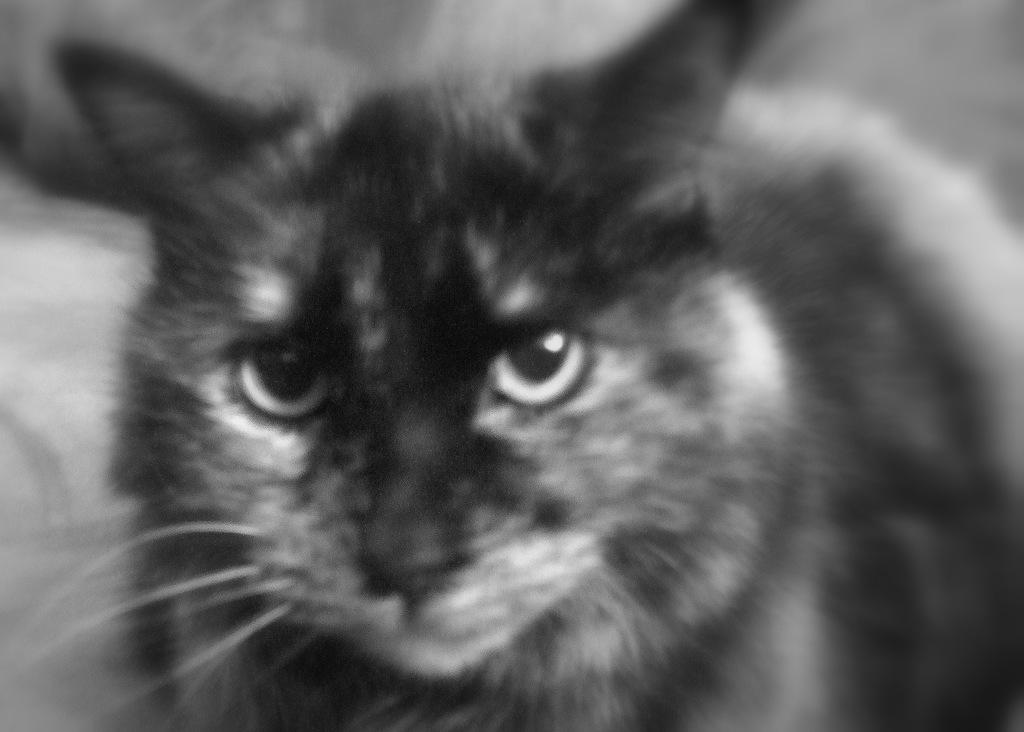What is the color scheme of the image? The image is black and white. What type of animal is present in the image? There is a cat in the image. What coloring does the cat have? The cat has both black and white coloring. What type of fowl can be seen in the image? There is no fowl present in the image; it features a cat with black and white coloring. Can you describe the wound on the cat in the image? There is no wound visible on the cat in the image. 